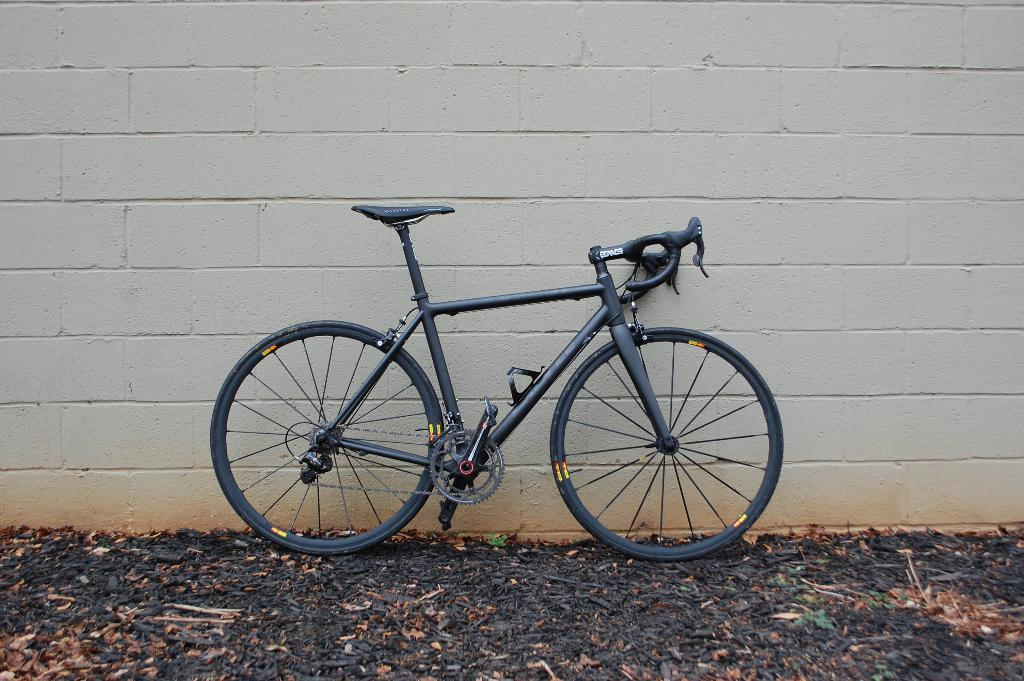What color is the bicycle in the image? The bicycle in the image is black. What color is the wall in the image? The wall in the image is white. What color are the objects on the ground in the image? The objects on the ground in the image are black. What type of wax can be seen melting on the bicycle in the image? There is no wax present in the image; the bicycle is simply black. How does the crib look in the image? There is no crib present in the image. 